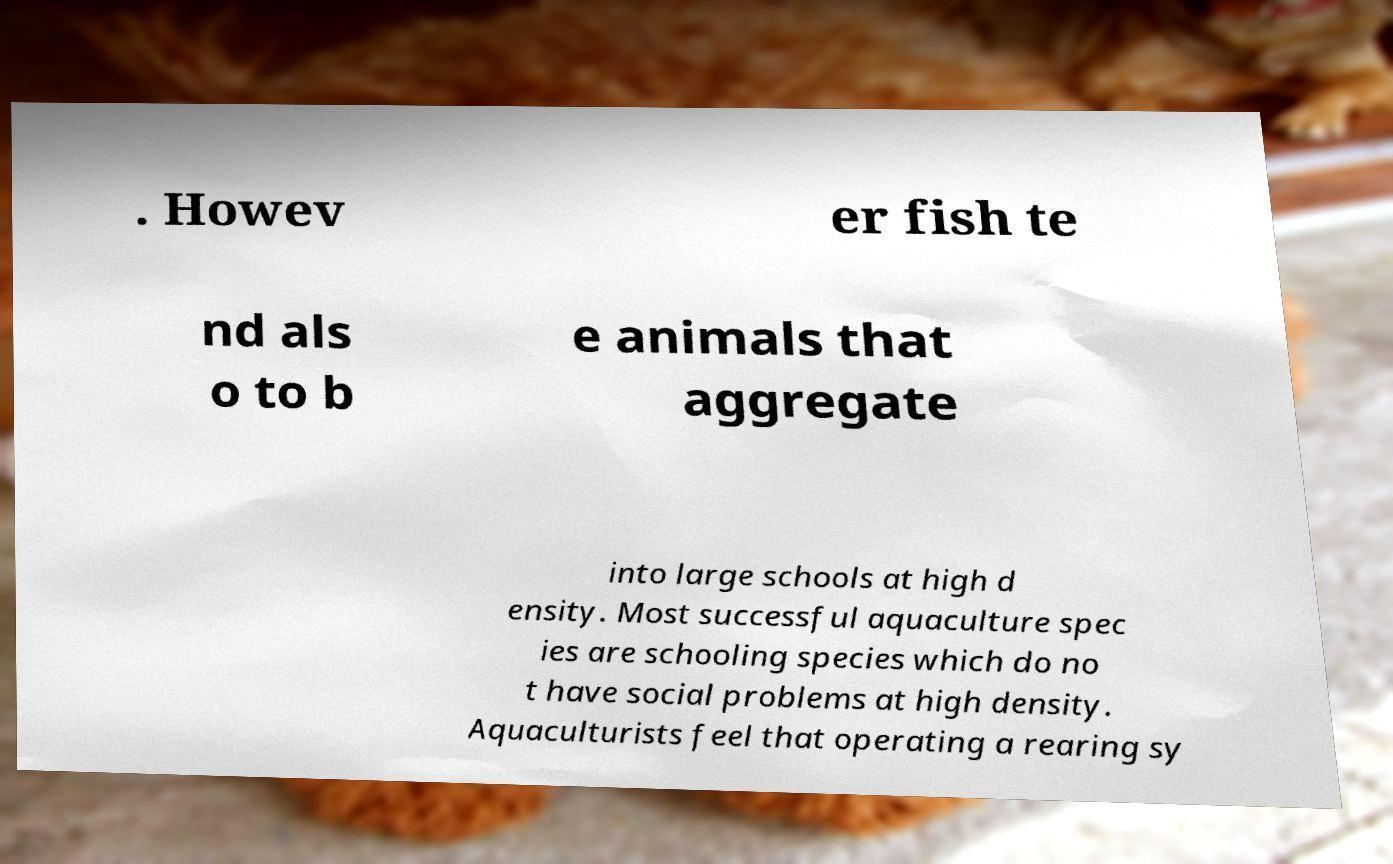What messages or text are displayed in this image? I need them in a readable, typed format. . Howev er fish te nd als o to b e animals that aggregate into large schools at high d ensity. Most successful aquaculture spec ies are schooling species which do no t have social problems at high density. Aquaculturists feel that operating a rearing sy 